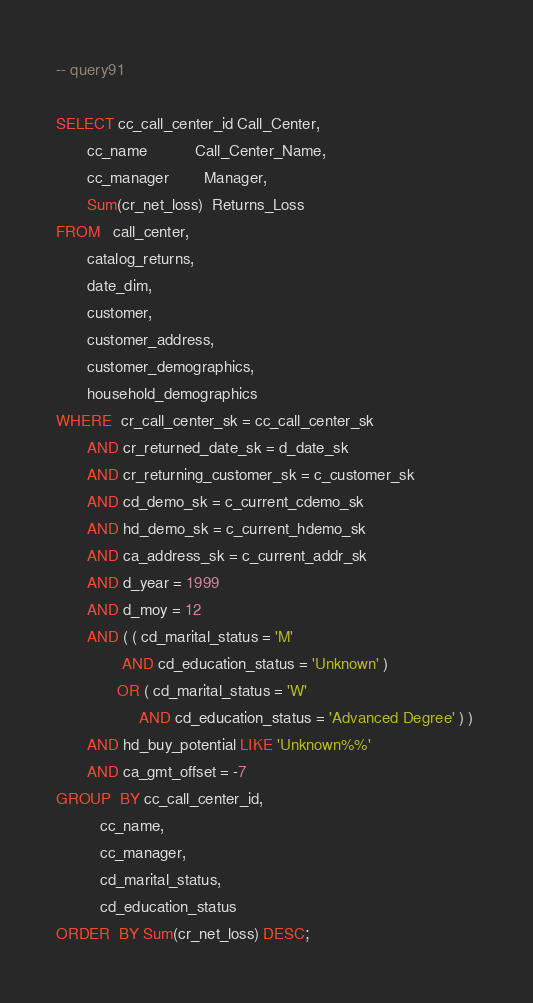<code> <loc_0><loc_0><loc_500><loc_500><_SQL_>-- query91

SELECT cc_call_center_id Call_Center, 
       cc_name           Call_Center_Name, 
       cc_manager        Manager, 
       Sum(cr_net_loss)  Returns_Loss 
FROM   call_center, 
       catalog_returns, 
       date_dim, 
       customer, 
       customer_address, 
       customer_demographics, 
       household_demographics 
WHERE  cr_call_center_sk = cc_call_center_sk 
       AND cr_returned_date_sk = d_date_sk 
       AND cr_returning_customer_sk = c_customer_sk 
       AND cd_demo_sk = c_current_cdemo_sk 
       AND hd_demo_sk = c_current_hdemo_sk 
       AND ca_address_sk = c_current_addr_sk 
       AND d_year = 1999 
       AND d_moy = 12 
       AND ( ( cd_marital_status = 'M' 
               AND cd_education_status = 'Unknown' ) 
              OR ( cd_marital_status = 'W' 
                   AND cd_education_status = 'Advanced Degree' ) ) 
       AND hd_buy_potential LIKE 'Unknown%%' 
       AND ca_gmt_offset = -7 
GROUP  BY cc_call_center_id, 
          cc_name, 
          cc_manager, 
          cd_marital_status, 
          cd_education_status 
ORDER  BY Sum(cr_net_loss) DESC; 

</code> 